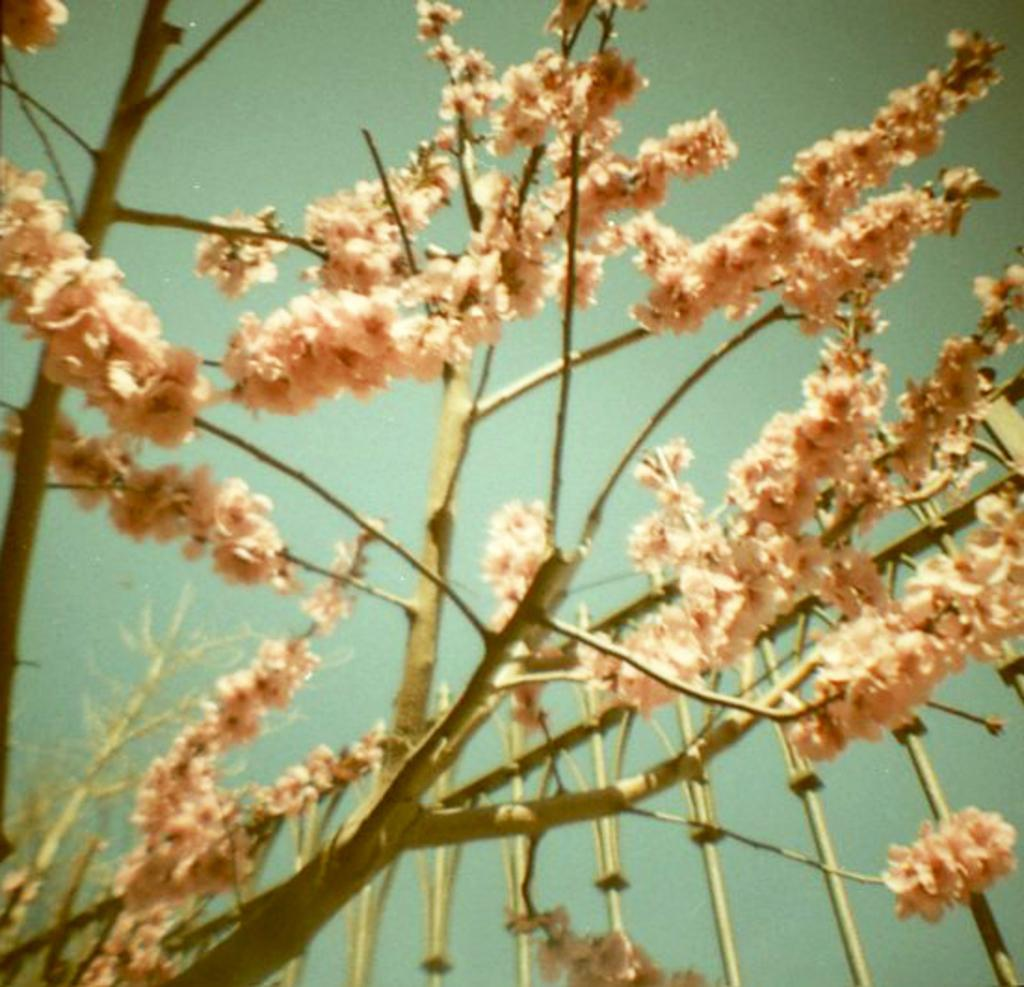What type of plant is present in the image? There are flowers with stems in the image. Where are the flowers located in the image? The flowers are in the middle of the image. What can be seen in the background of the image? There is a sky visible in the background of the image. What type of yoke is being used by the goat in the image? There is no goat or yoke present in the image; it features flowers with stems and a sky visible in the background. 